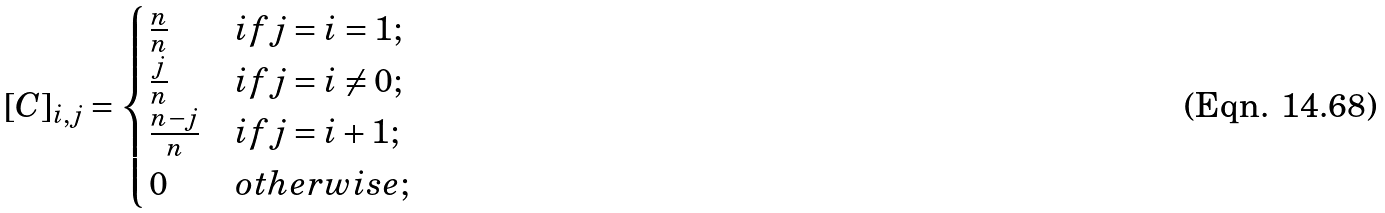<formula> <loc_0><loc_0><loc_500><loc_500>\left [ C \right ] _ { i , j } = \begin{cases} \frac { n } { n } & i f j = i = 1 ; \\ \frac { j } { n } & i f j = i \neq 0 ; \\ \frac { n - j } { n } & i f j = i + 1 ; \\ 0 & o t h e r w i s e ; \end{cases}</formula> 